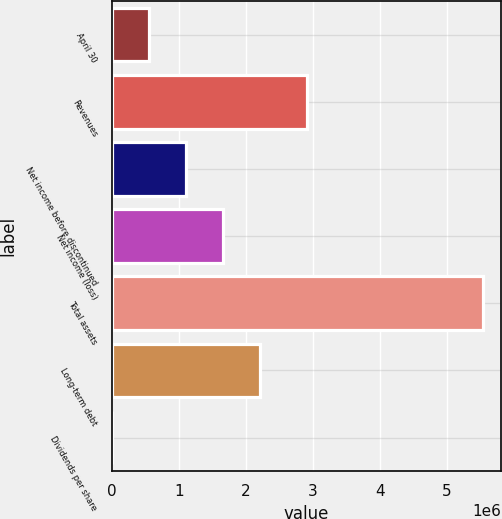<chart> <loc_0><loc_0><loc_500><loc_500><bar_chart><fcel>April 30<fcel>Revenues<fcel>Net income before discontinued<fcel>Net income (loss)<fcel>Total assets<fcel>Long-term debt<fcel>Dividends per share<nl><fcel>553806<fcel>2.90712e+06<fcel>1.10761e+06<fcel>1.66142e+06<fcel>5.53806e+06<fcel>2.21522e+06<fcel>0.43<nl></chart> 